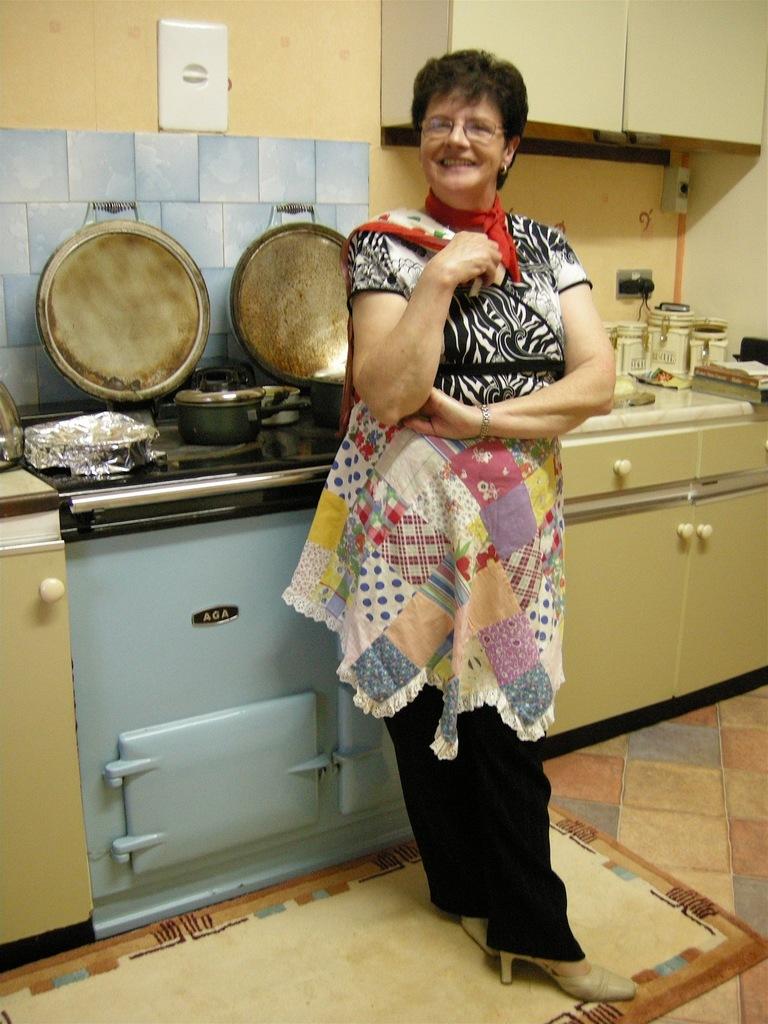What stove brand is that?
Your answer should be very brief. Aga. 